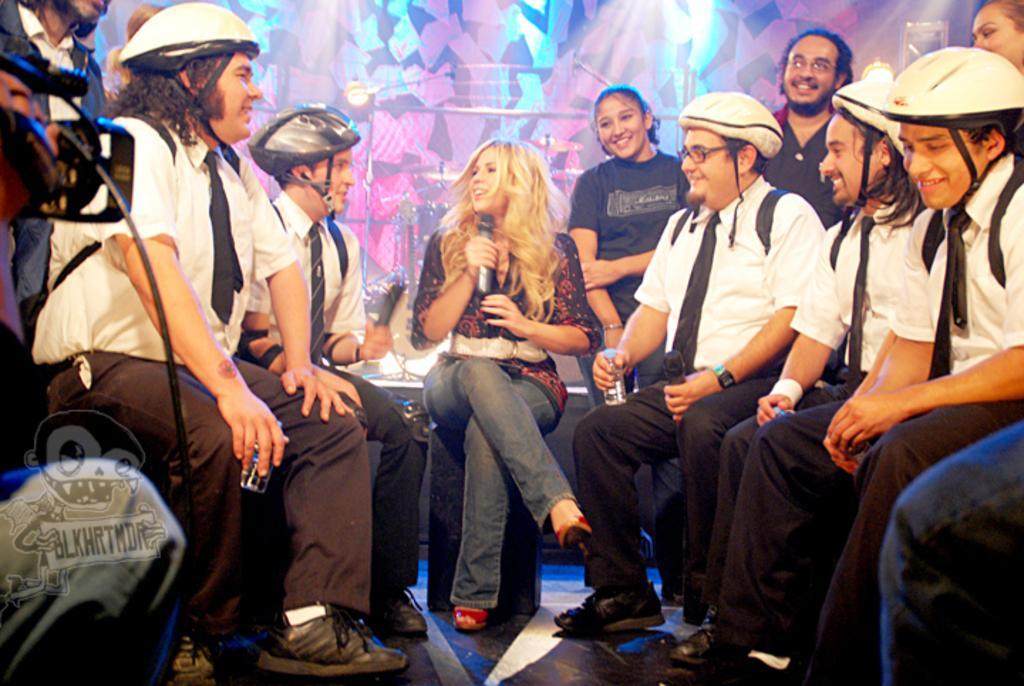How would you summarize this image in a sentence or two? In this image I can see number of persons are sitting and I can see they are wearing helmets and a person is holding a microphone. I can see a person is holding a camera to the left side of the image. In the background I can see few metal rods, few lights and few colorful objects. 